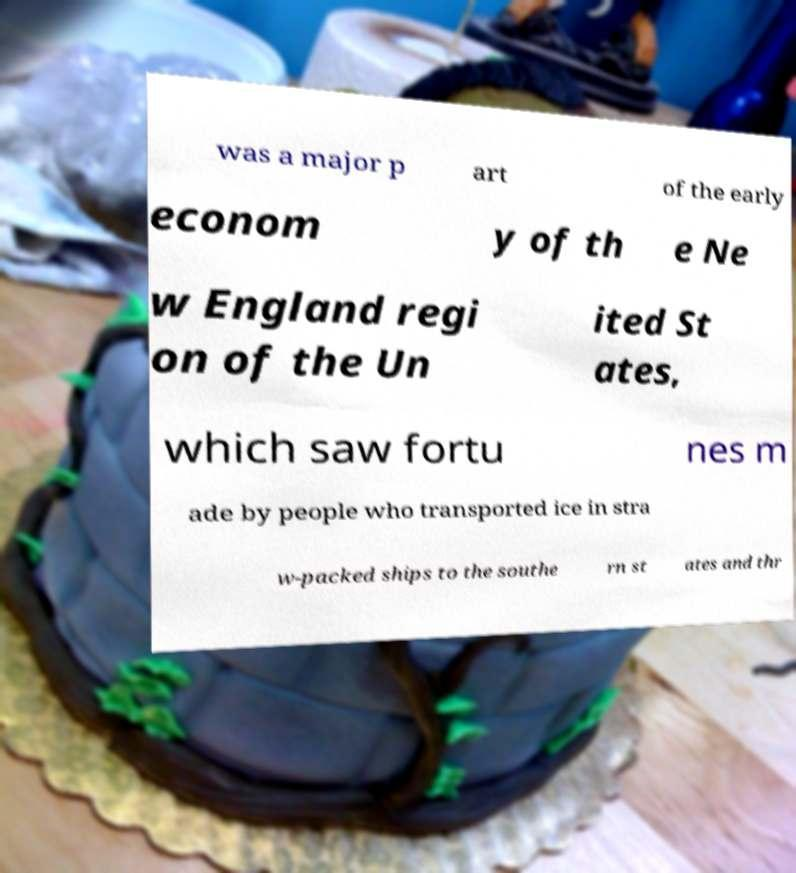What messages or text are displayed in this image? I need them in a readable, typed format. was a major p art of the early econom y of th e Ne w England regi on of the Un ited St ates, which saw fortu nes m ade by people who transported ice in stra w-packed ships to the southe rn st ates and thr 